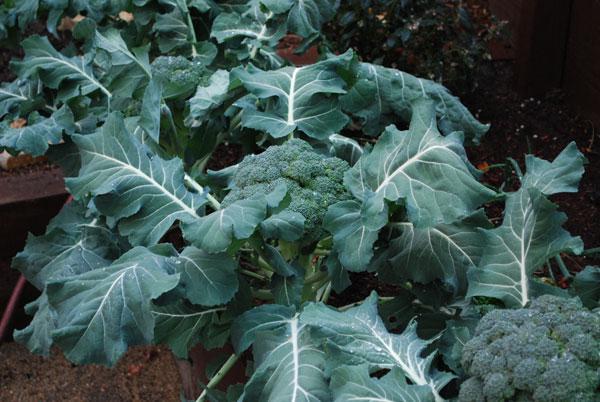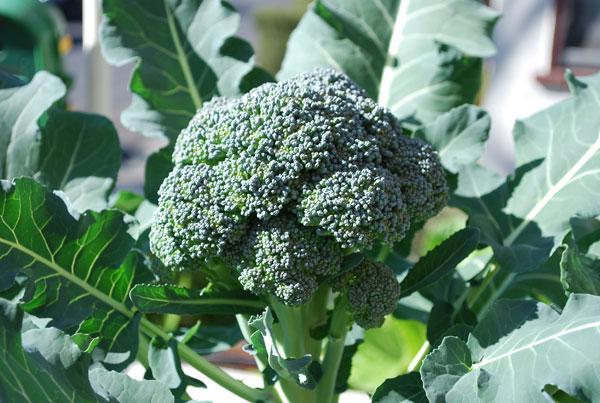The first image is the image on the left, the second image is the image on the right. For the images shown, is this caption "The left and right image contains the same number broccoli heads growing straight up." true? Answer yes or no. No. 